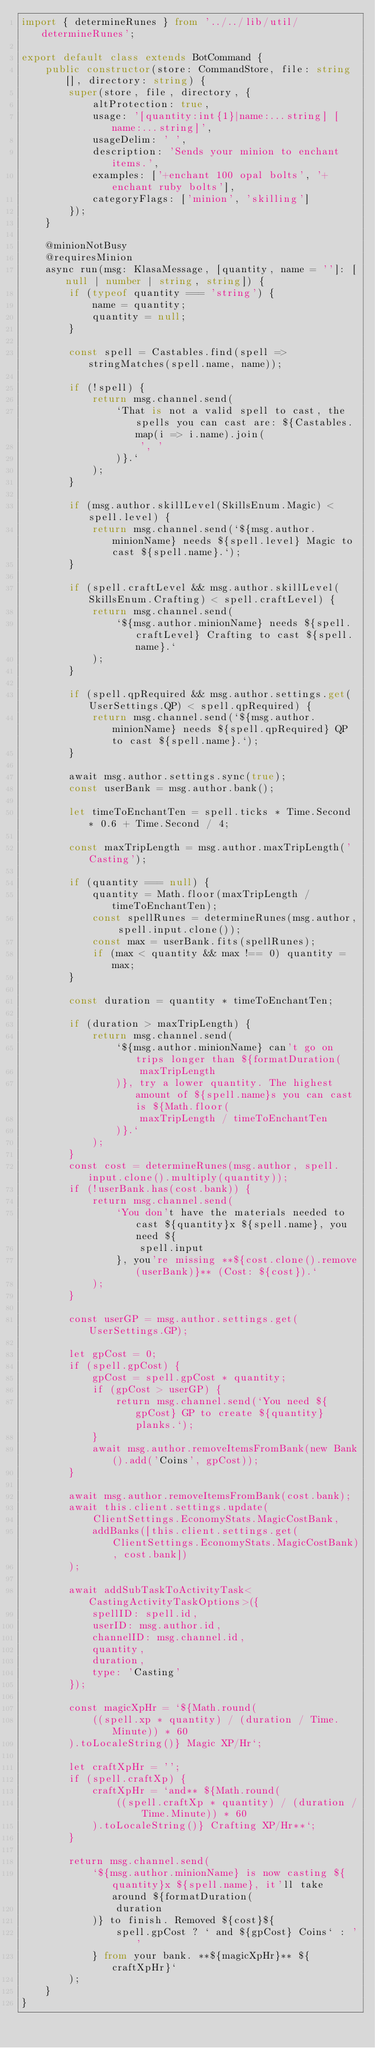<code> <loc_0><loc_0><loc_500><loc_500><_TypeScript_>import { determineRunes } from '../../lib/util/determineRunes';

export default class extends BotCommand {
	public constructor(store: CommandStore, file: string[], directory: string) {
		super(store, file, directory, {
			altProtection: true,
			usage: '[quantity:int{1}|name:...string] [name:...string]',
			usageDelim: ' ',
			description: 'Sends your minion to enchant items.',
			examples: ['+enchant 100 opal bolts', '+enchant ruby bolts'],
			categoryFlags: ['minion', 'skilling']
		});
	}

	@minionNotBusy
	@requiresMinion
	async run(msg: KlasaMessage, [quantity, name = '']: [null | number | string, string]) {
		if (typeof quantity === 'string') {
			name = quantity;
			quantity = null;
		}

		const spell = Castables.find(spell => stringMatches(spell.name, name));

		if (!spell) {
			return msg.channel.send(
				`That is not a valid spell to cast, the spells you can cast are: ${Castables.map(i => i.name).join(
					', '
				)}.`
			);
		}

		if (msg.author.skillLevel(SkillsEnum.Magic) < spell.level) {
			return msg.channel.send(`${msg.author.minionName} needs ${spell.level} Magic to cast ${spell.name}.`);
		}

		if (spell.craftLevel && msg.author.skillLevel(SkillsEnum.Crafting) < spell.craftLevel) {
			return msg.channel.send(
				`${msg.author.minionName} needs ${spell.craftLevel} Crafting to cast ${spell.name}.`
			);
		}

		if (spell.qpRequired && msg.author.settings.get(UserSettings.QP) < spell.qpRequired) {
			return msg.channel.send(`${msg.author.minionName} needs ${spell.qpRequired} QP to cast ${spell.name}.`);
		}

		await msg.author.settings.sync(true);
		const userBank = msg.author.bank();

		let timeToEnchantTen = spell.ticks * Time.Second * 0.6 + Time.Second / 4;

		const maxTripLength = msg.author.maxTripLength('Casting');

		if (quantity === null) {
			quantity = Math.floor(maxTripLength / timeToEnchantTen);
			const spellRunes = determineRunes(msg.author, spell.input.clone());
			const max = userBank.fits(spellRunes);
			if (max < quantity && max !== 0) quantity = max;
		}

		const duration = quantity * timeToEnchantTen;

		if (duration > maxTripLength) {
			return msg.channel.send(
				`${msg.author.minionName} can't go on trips longer than ${formatDuration(
					maxTripLength
				)}, try a lower quantity. The highest amount of ${spell.name}s you can cast is ${Math.floor(
					maxTripLength / timeToEnchantTen
				)}.`
			);
		}
		const cost = determineRunes(msg.author, spell.input.clone().multiply(quantity));
		if (!userBank.has(cost.bank)) {
			return msg.channel.send(
				`You don't have the materials needed to cast ${quantity}x ${spell.name}, you need ${
					spell.input
				}, you're missing **${cost.clone().remove(userBank)}** (Cost: ${cost}).`
			);
		}

		const userGP = msg.author.settings.get(UserSettings.GP);

		let gpCost = 0;
		if (spell.gpCost) {
			gpCost = spell.gpCost * quantity;
			if (gpCost > userGP) {
				return msg.channel.send(`You need ${gpCost} GP to create ${quantity} planks.`);
			}
			await msg.author.removeItemsFromBank(new Bank().add('Coins', gpCost));
		}

		await msg.author.removeItemsFromBank(cost.bank);
		await this.client.settings.update(
			ClientSettings.EconomyStats.MagicCostBank,
			addBanks([this.client.settings.get(ClientSettings.EconomyStats.MagicCostBank), cost.bank])
		);

		await addSubTaskToActivityTask<CastingActivityTaskOptions>({
			spellID: spell.id,
			userID: msg.author.id,
			channelID: msg.channel.id,
			quantity,
			duration,
			type: 'Casting'
		});

		const magicXpHr = `${Math.round(
			((spell.xp * quantity) / (duration / Time.Minute)) * 60
		).toLocaleString()} Magic XP/Hr`;

		let craftXpHr = '';
		if (spell.craftXp) {
			craftXpHr = `and** ${Math.round(
				((spell.craftXp * quantity) / (duration / Time.Minute)) * 60
			).toLocaleString()} Crafting XP/Hr**`;
		}

		return msg.channel.send(
			`${msg.author.minionName} is now casting ${quantity}x ${spell.name}, it'll take around ${formatDuration(
				duration
			)} to finish. Removed ${cost}${
				spell.gpCost ? ` and ${gpCost} Coins` : ''
			} from your bank. **${magicXpHr}** ${craftXpHr}`
		);
	}
}
</code> 